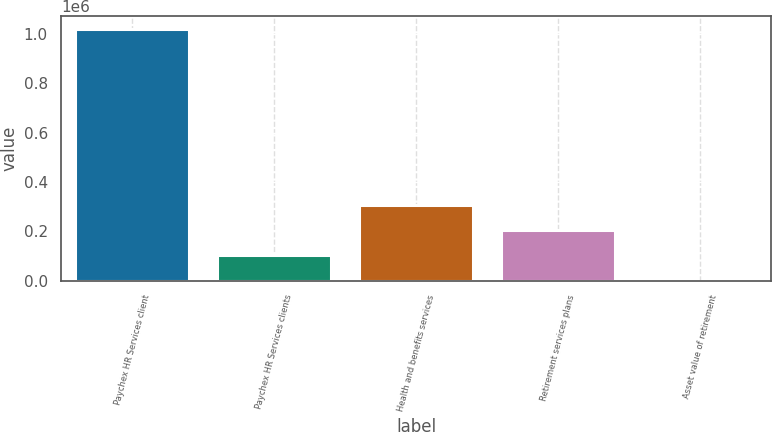<chart> <loc_0><loc_0><loc_500><loc_500><bar_chart><fcel>Paychex HR Services client<fcel>Paychex HR Services clients<fcel>Health and benefits services<fcel>Retirement services plans<fcel>Asset value of retirement<nl><fcel>1.021e+06<fcel>102125<fcel>306319<fcel>204222<fcel>27.4<nl></chart> 